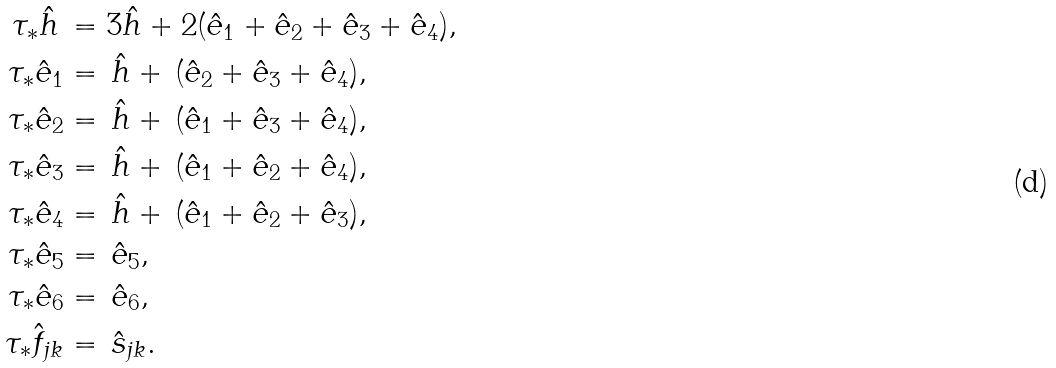<formula> <loc_0><loc_0><loc_500><loc_500>\tau _ { * } \hat { h } \, & = 3 \hat { h } + 2 ( \hat { e } _ { 1 } + \hat { e } _ { 2 } + \hat { e } _ { 3 } + \hat { e } _ { 4 } ) , \\ \tau _ { * } \hat { e } _ { 1 } & = \, \hat { h } + \, ( \hat { e } _ { 2 } + \hat { e } _ { 3 } + \hat { e } _ { 4 } ) , \\ \tau _ { * } \hat { e } _ { 2 } & = \, \hat { h } + \, ( \hat { e } _ { 1 } + \hat { e } _ { 3 } + \hat { e } _ { 4 } ) , \\ \tau _ { * } \hat { e } _ { 3 } & = \, \hat { h } + \, ( \hat { e } _ { 1 } + \hat { e } _ { 2 } + \hat { e } _ { 4 } ) , \\ \tau _ { * } \hat { e } _ { 4 } & = \, \hat { h } + \, ( \hat { e } _ { 1 } + \hat { e } _ { 2 } + \hat { e } _ { 3 } ) , \\ \tau _ { * } \hat { e } _ { 5 } & = \, \hat { e } _ { 5 } , \\ \tau _ { * } \hat { e } _ { 6 } & = \, \hat { e } _ { 6 } , \\ \tau _ { * } \hat { f } _ { j k } & = \, \hat { s } _ { j k } .</formula> 